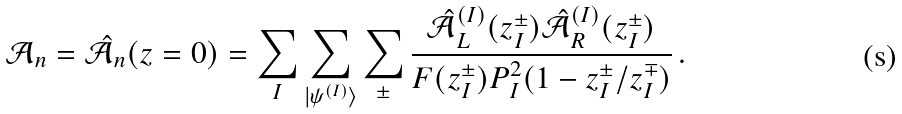<formula> <loc_0><loc_0><loc_500><loc_500>\mathcal { A } _ { n } = \hat { \mathcal { A } } _ { n } ( z = 0 ) = \sum _ { I } \sum _ { | \psi ^ { ( I ) } \rangle } \sum _ { \pm } \frac { \hat { \mathcal { A } } _ { L } ^ { ( I ) } ( z _ { I } ^ { \pm } ) \hat { \mathcal { A } } _ { R } ^ { ( I ) } ( z _ { I } ^ { \pm } ) } { F ( z _ { I } ^ { \pm } ) P _ { I } ^ { 2 } ( 1 - z _ { I } ^ { \pm } / z _ { I } ^ { \mp } ) } \, .</formula> 